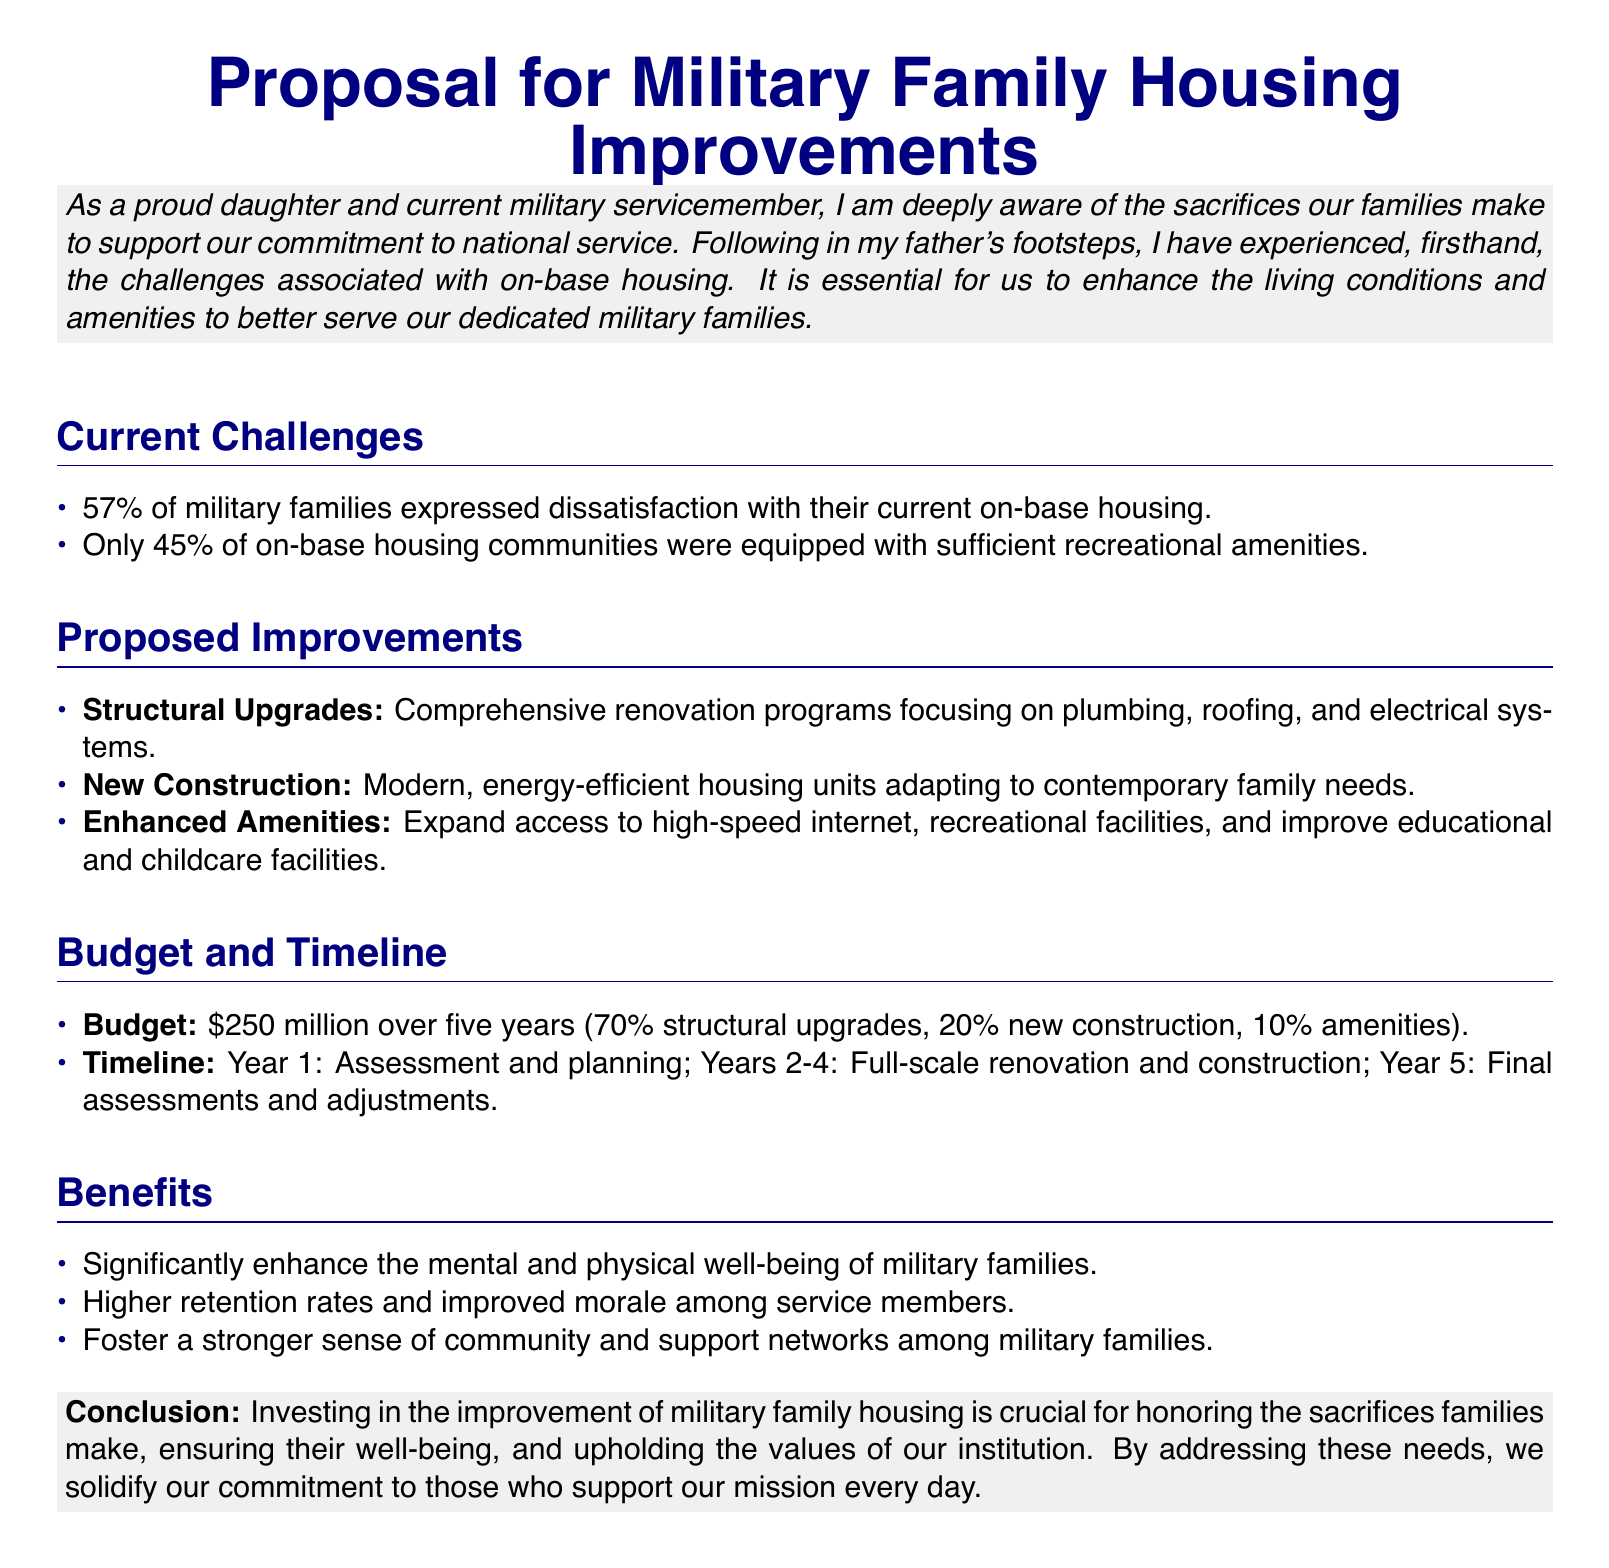What percentage of military families expressed dissatisfaction with their current housing? The document states that 57% of military families expressed dissatisfaction with their current on-base housing.
Answer: 57% What is the budget allocated for the housing improvements? The budget proposed for military family housing improvements is detailed in the document as $250 million over five years.
Answer: $250 million What percentage of the budget is allocated to structural upgrades? The document specifies that 70% of the budget is allocated to structural upgrades.
Answer: 70% What is the timeline for the assessment and planning phase? The document indicates that the assessment and planning phase will take place in Year 1.
Answer: Year 1 Which aspect of military family life is significantly enhanced according to the proposal? The proposal indicates that the improvements will significantly enhance the mental and physical well-being of military families.
Answer: Mental and physical well-being What types of new housing units are proposed? The document suggests modern, energy-efficient housing units designed to adapt to contemporary family needs.
Answer: Modern, energy-efficient housing units What is one of the proposed enhancements related to amenities? The document states that one proposed enhancement is to expand access to high-speed internet.
Answer: High-speed internet How many years will it take to complete the full-scale renovation and construction? According to the proposal, full-scale renovation and construction will take place over Years 2-4, which is a span of three years.
Answer: Three years What is the conclusion of the proposal? The conclusion emphasizes the importance of investing in military family housing to honor sacrifices and ensure well-being.
Answer: Investing in improvement is crucial for honoring sacrifices 